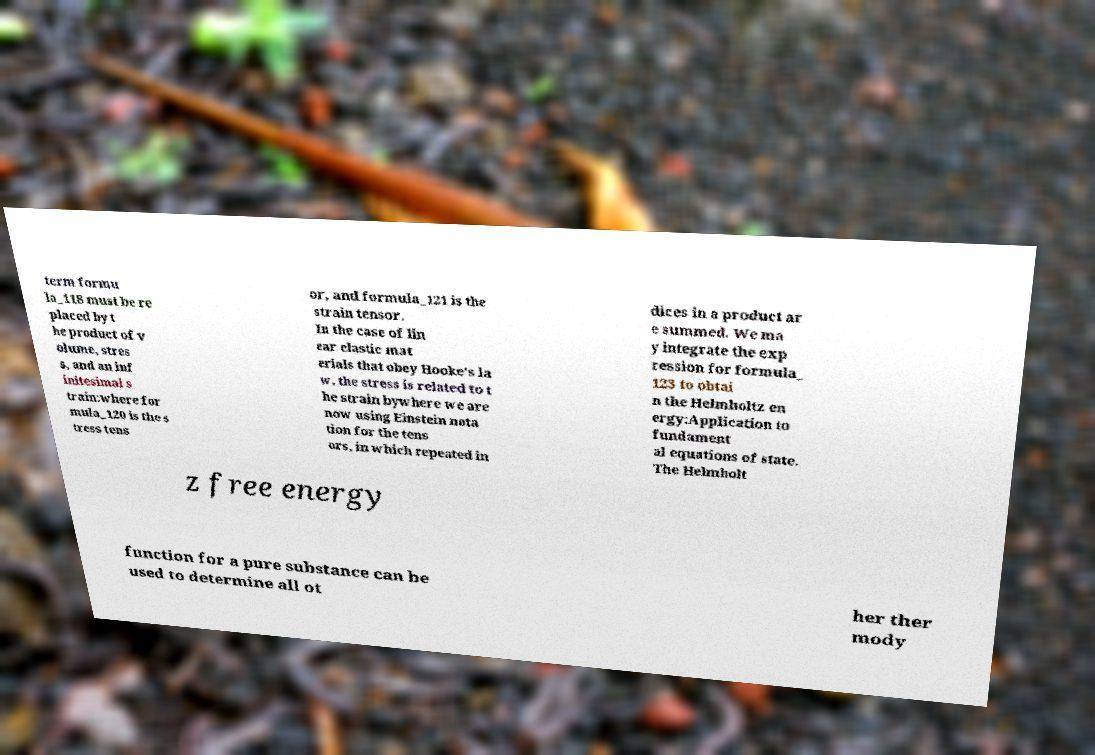Please read and relay the text visible in this image. What does it say? term formu la_118 must be re placed by t he product of v olume, stres s, and an inf initesimal s train:where for mula_120 is the s tress tens or, and formula_121 is the strain tensor. In the case of lin ear elastic mat erials that obey Hooke's la w, the stress is related to t he strain bywhere we are now using Einstein nota tion for the tens ors, in which repeated in dices in a product ar e summed. We ma y integrate the exp ression for formula_ 123 to obtai n the Helmholtz en ergy:Application to fundament al equations of state. The Helmholt z free energy function for a pure substance can be used to determine all ot her ther mody 